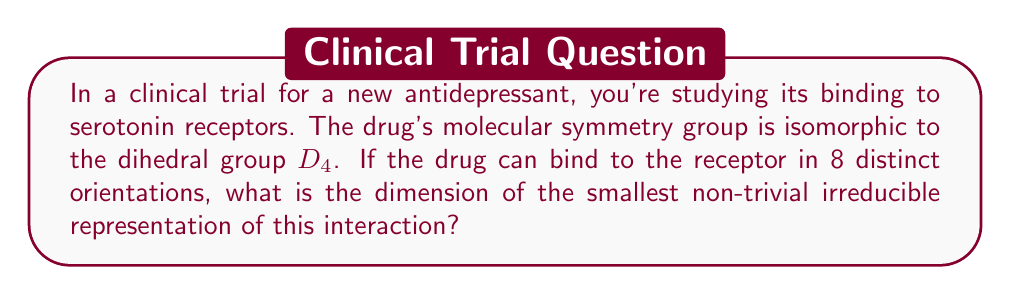Solve this math problem. Let's approach this step-by-step:

1) The dihedral group $D_4$ has order 8, corresponding to the 8 distinct orientations of the drug binding to the receptor.

2) For finite groups, the number of irreducible representations is equal to the number of conjugacy classes. $D_4$ has 5 conjugacy classes.

3) The irreducible representations of $D_4$ have dimensions:
   $$1, 1, 1, 1, 2$$

4) The sum of the squares of these dimensions equals the order of the group:
   $$1^2 + 1^2 + 1^2 + 1^2 + 2^2 = 8$$

5) The trivial representation always has dimension 1, so we're looking for the smallest non-trivial irreducible representation.

6) Among the non-trivial representations, we have four 1-dimensional representations and one 2-dimensional representation.

7) Therefore, the smallest non-trivial irreducible representation has dimension 1.

This 1-dimensional representation could model a simple aspect of the drug-receptor interaction, such as whether the drug is bound or unbound, while the 2-dimensional representation might capture more complex aspects of the binding orientation.
Answer: 1 